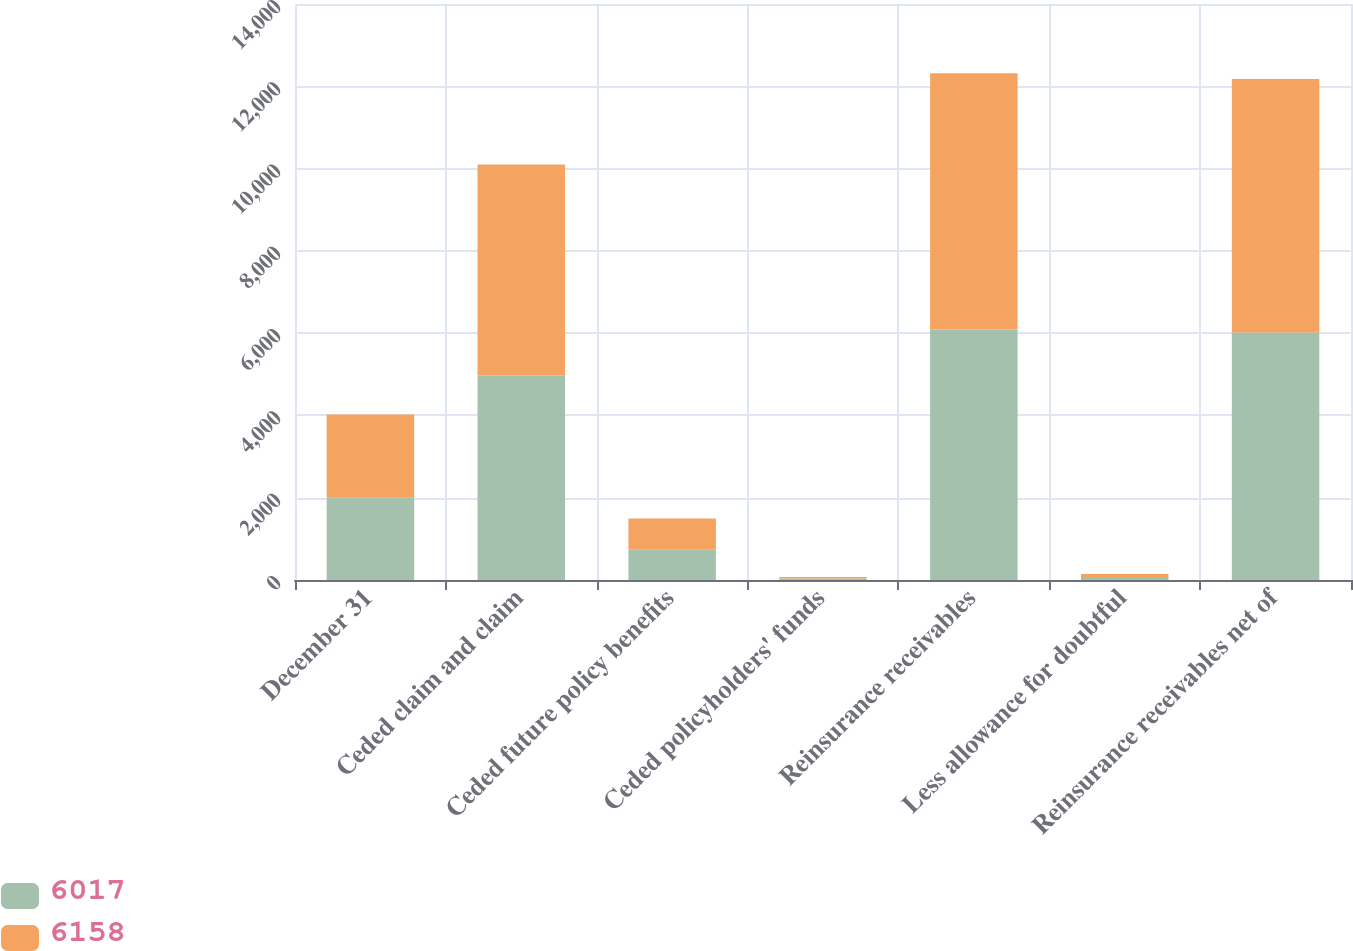Convert chart. <chart><loc_0><loc_0><loc_500><loc_500><stacked_bar_chart><ecel><fcel>December 31<fcel>Ceded claim and claim<fcel>Ceded future policy benefits<fcel>Ceded policyholders' funds<fcel>Reinsurance receivables<fcel>Less allowance for doubtful<fcel>Reinsurance receivables net of<nl><fcel>6017<fcel>2013<fcel>4972<fcel>733<fcel>35<fcel>6088<fcel>71<fcel>6017<nl><fcel>6158<fcel>2012<fcel>5126<fcel>759<fcel>35<fcel>6231<fcel>73<fcel>6158<nl></chart> 